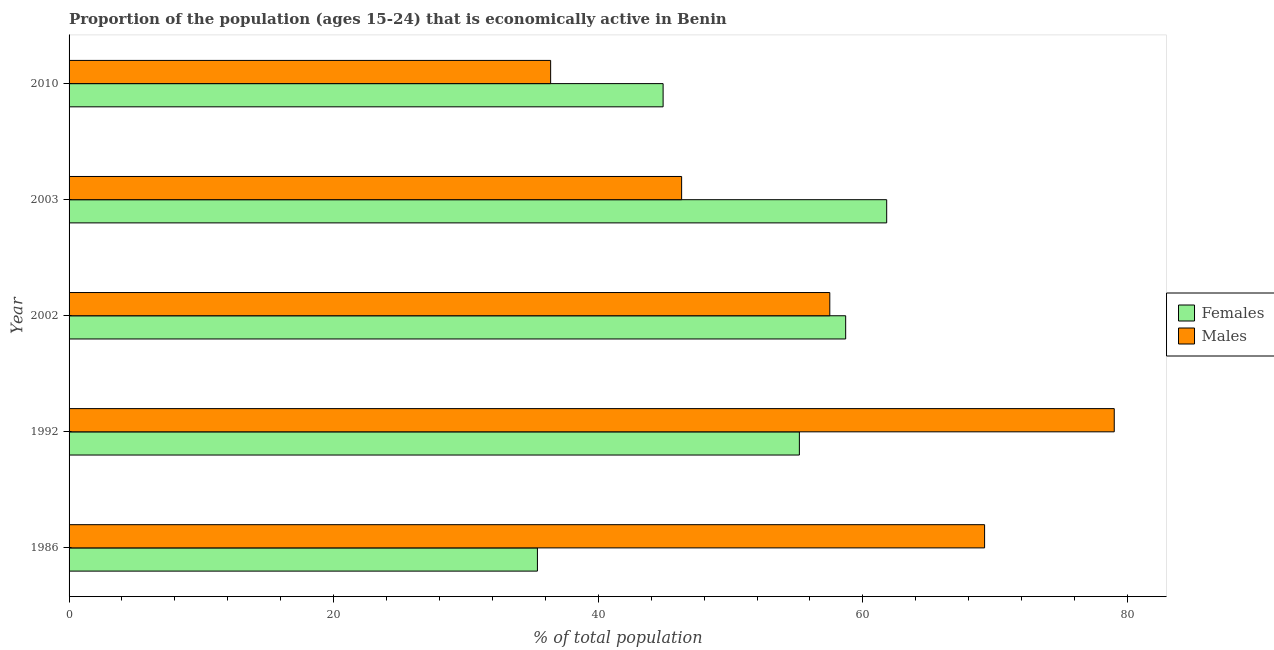Are the number of bars per tick equal to the number of legend labels?
Give a very brief answer. Yes. How many bars are there on the 3rd tick from the top?
Your answer should be compact. 2. What is the percentage of economically active male population in 2003?
Your answer should be compact. 46.3. Across all years, what is the maximum percentage of economically active female population?
Your response must be concise. 61.8. Across all years, what is the minimum percentage of economically active male population?
Provide a short and direct response. 36.4. In which year was the percentage of economically active female population minimum?
Your answer should be compact. 1986. What is the total percentage of economically active male population in the graph?
Your answer should be very brief. 288.4. What is the difference between the percentage of economically active male population in 1992 and that in 2003?
Provide a short and direct response. 32.7. What is the difference between the percentage of economically active male population in 2010 and the percentage of economically active female population in 1992?
Keep it short and to the point. -18.8. What is the average percentage of economically active male population per year?
Provide a short and direct response. 57.68. In the year 2003, what is the difference between the percentage of economically active male population and percentage of economically active female population?
Keep it short and to the point. -15.5. What is the ratio of the percentage of economically active female population in 1992 to that in 2010?
Offer a very short reply. 1.23. Is the percentage of economically active male population in 2003 less than that in 2010?
Keep it short and to the point. No. What is the difference between the highest and the lowest percentage of economically active male population?
Give a very brief answer. 42.6. What does the 1st bar from the top in 2002 represents?
Your answer should be compact. Males. What does the 1st bar from the bottom in 2003 represents?
Give a very brief answer. Females. How many years are there in the graph?
Provide a succinct answer. 5. Are the values on the major ticks of X-axis written in scientific E-notation?
Provide a short and direct response. No. Does the graph contain any zero values?
Provide a succinct answer. No. Does the graph contain grids?
Make the answer very short. No. What is the title of the graph?
Keep it short and to the point. Proportion of the population (ages 15-24) that is economically active in Benin. Does "Primary income" appear as one of the legend labels in the graph?
Your response must be concise. No. What is the label or title of the X-axis?
Provide a short and direct response. % of total population. What is the label or title of the Y-axis?
Give a very brief answer. Year. What is the % of total population of Females in 1986?
Your response must be concise. 35.4. What is the % of total population of Males in 1986?
Keep it short and to the point. 69.2. What is the % of total population of Females in 1992?
Your response must be concise. 55.2. What is the % of total population in Males in 1992?
Provide a succinct answer. 79. What is the % of total population in Females in 2002?
Provide a short and direct response. 58.7. What is the % of total population of Males in 2002?
Keep it short and to the point. 57.5. What is the % of total population of Females in 2003?
Your response must be concise. 61.8. What is the % of total population of Males in 2003?
Offer a terse response. 46.3. What is the % of total population in Females in 2010?
Give a very brief answer. 44.9. What is the % of total population in Males in 2010?
Offer a very short reply. 36.4. Across all years, what is the maximum % of total population in Females?
Your answer should be very brief. 61.8. Across all years, what is the maximum % of total population in Males?
Provide a short and direct response. 79. Across all years, what is the minimum % of total population of Females?
Make the answer very short. 35.4. Across all years, what is the minimum % of total population of Males?
Keep it short and to the point. 36.4. What is the total % of total population in Females in the graph?
Keep it short and to the point. 256. What is the total % of total population in Males in the graph?
Provide a succinct answer. 288.4. What is the difference between the % of total population of Females in 1986 and that in 1992?
Make the answer very short. -19.8. What is the difference between the % of total population of Males in 1986 and that in 1992?
Provide a succinct answer. -9.8. What is the difference between the % of total population in Females in 1986 and that in 2002?
Offer a terse response. -23.3. What is the difference between the % of total population in Males in 1986 and that in 2002?
Give a very brief answer. 11.7. What is the difference between the % of total population of Females in 1986 and that in 2003?
Keep it short and to the point. -26.4. What is the difference between the % of total population in Males in 1986 and that in 2003?
Offer a terse response. 22.9. What is the difference between the % of total population in Males in 1986 and that in 2010?
Keep it short and to the point. 32.8. What is the difference between the % of total population of Females in 1992 and that in 2002?
Offer a terse response. -3.5. What is the difference between the % of total population of Males in 1992 and that in 2002?
Provide a succinct answer. 21.5. What is the difference between the % of total population of Females in 1992 and that in 2003?
Offer a terse response. -6.6. What is the difference between the % of total population in Males in 1992 and that in 2003?
Your answer should be very brief. 32.7. What is the difference between the % of total population of Females in 1992 and that in 2010?
Give a very brief answer. 10.3. What is the difference between the % of total population of Males in 1992 and that in 2010?
Provide a succinct answer. 42.6. What is the difference between the % of total population of Males in 2002 and that in 2010?
Give a very brief answer. 21.1. What is the difference between the % of total population of Females in 2003 and that in 2010?
Your answer should be compact. 16.9. What is the difference between the % of total population of Males in 2003 and that in 2010?
Keep it short and to the point. 9.9. What is the difference between the % of total population of Females in 1986 and the % of total population of Males in 1992?
Give a very brief answer. -43.6. What is the difference between the % of total population in Females in 1986 and the % of total population in Males in 2002?
Make the answer very short. -22.1. What is the difference between the % of total population of Females in 1986 and the % of total population of Males in 2003?
Provide a short and direct response. -10.9. What is the difference between the % of total population of Females in 1986 and the % of total population of Males in 2010?
Keep it short and to the point. -1. What is the difference between the % of total population in Females in 1992 and the % of total population in Males in 2010?
Provide a succinct answer. 18.8. What is the difference between the % of total population in Females in 2002 and the % of total population in Males in 2010?
Keep it short and to the point. 22.3. What is the difference between the % of total population in Females in 2003 and the % of total population in Males in 2010?
Your answer should be very brief. 25.4. What is the average % of total population in Females per year?
Keep it short and to the point. 51.2. What is the average % of total population in Males per year?
Your answer should be very brief. 57.68. In the year 1986, what is the difference between the % of total population in Females and % of total population in Males?
Make the answer very short. -33.8. In the year 1992, what is the difference between the % of total population of Females and % of total population of Males?
Ensure brevity in your answer.  -23.8. In the year 2003, what is the difference between the % of total population of Females and % of total population of Males?
Ensure brevity in your answer.  15.5. What is the ratio of the % of total population in Females in 1986 to that in 1992?
Your response must be concise. 0.64. What is the ratio of the % of total population of Males in 1986 to that in 1992?
Ensure brevity in your answer.  0.88. What is the ratio of the % of total population in Females in 1986 to that in 2002?
Give a very brief answer. 0.6. What is the ratio of the % of total population of Males in 1986 to that in 2002?
Keep it short and to the point. 1.2. What is the ratio of the % of total population of Females in 1986 to that in 2003?
Give a very brief answer. 0.57. What is the ratio of the % of total population of Males in 1986 to that in 2003?
Keep it short and to the point. 1.49. What is the ratio of the % of total population of Females in 1986 to that in 2010?
Give a very brief answer. 0.79. What is the ratio of the % of total population in Males in 1986 to that in 2010?
Offer a terse response. 1.9. What is the ratio of the % of total population of Females in 1992 to that in 2002?
Keep it short and to the point. 0.94. What is the ratio of the % of total population in Males in 1992 to that in 2002?
Make the answer very short. 1.37. What is the ratio of the % of total population in Females in 1992 to that in 2003?
Your answer should be compact. 0.89. What is the ratio of the % of total population of Males in 1992 to that in 2003?
Your answer should be very brief. 1.71. What is the ratio of the % of total population in Females in 1992 to that in 2010?
Provide a succinct answer. 1.23. What is the ratio of the % of total population of Males in 1992 to that in 2010?
Provide a short and direct response. 2.17. What is the ratio of the % of total population in Females in 2002 to that in 2003?
Provide a short and direct response. 0.95. What is the ratio of the % of total population in Males in 2002 to that in 2003?
Your answer should be compact. 1.24. What is the ratio of the % of total population of Females in 2002 to that in 2010?
Make the answer very short. 1.31. What is the ratio of the % of total population of Males in 2002 to that in 2010?
Your answer should be very brief. 1.58. What is the ratio of the % of total population in Females in 2003 to that in 2010?
Your answer should be compact. 1.38. What is the ratio of the % of total population of Males in 2003 to that in 2010?
Your response must be concise. 1.27. What is the difference between the highest and the second highest % of total population of Females?
Give a very brief answer. 3.1. What is the difference between the highest and the second highest % of total population in Males?
Your answer should be very brief. 9.8. What is the difference between the highest and the lowest % of total population in Females?
Offer a very short reply. 26.4. What is the difference between the highest and the lowest % of total population of Males?
Provide a succinct answer. 42.6. 